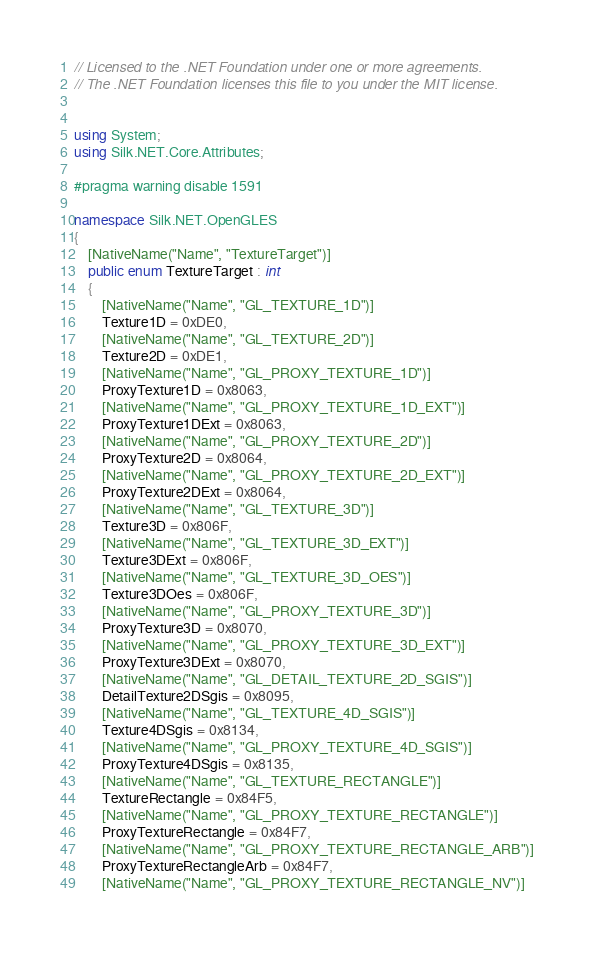<code> <loc_0><loc_0><loc_500><loc_500><_C#_>// Licensed to the .NET Foundation under one or more agreements.
// The .NET Foundation licenses this file to you under the MIT license.


using System;
using Silk.NET.Core.Attributes;

#pragma warning disable 1591

namespace Silk.NET.OpenGLES
{
    [NativeName("Name", "TextureTarget")]
    public enum TextureTarget : int
    {
        [NativeName("Name", "GL_TEXTURE_1D")]
        Texture1D = 0xDE0,
        [NativeName("Name", "GL_TEXTURE_2D")]
        Texture2D = 0xDE1,
        [NativeName("Name", "GL_PROXY_TEXTURE_1D")]
        ProxyTexture1D = 0x8063,
        [NativeName("Name", "GL_PROXY_TEXTURE_1D_EXT")]
        ProxyTexture1DExt = 0x8063,
        [NativeName("Name", "GL_PROXY_TEXTURE_2D")]
        ProxyTexture2D = 0x8064,
        [NativeName("Name", "GL_PROXY_TEXTURE_2D_EXT")]
        ProxyTexture2DExt = 0x8064,
        [NativeName("Name", "GL_TEXTURE_3D")]
        Texture3D = 0x806F,
        [NativeName("Name", "GL_TEXTURE_3D_EXT")]
        Texture3DExt = 0x806F,
        [NativeName("Name", "GL_TEXTURE_3D_OES")]
        Texture3DOes = 0x806F,
        [NativeName("Name", "GL_PROXY_TEXTURE_3D")]
        ProxyTexture3D = 0x8070,
        [NativeName("Name", "GL_PROXY_TEXTURE_3D_EXT")]
        ProxyTexture3DExt = 0x8070,
        [NativeName("Name", "GL_DETAIL_TEXTURE_2D_SGIS")]
        DetailTexture2DSgis = 0x8095,
        [NativeName("Name", "GL_TEXTURE_4D_SGIS")]
        Texture4DSgis = 0x8134,
        [NativeName("Name", "GL_PROXY_TEXTURE_4D_SGIS")]
        ProxyTexture4DSgis = 0x8135,
        [NativeName("Name", "GL_TEXTURE_RECTANGLE")]
        TextureRectangle = 0x84F5,
        [NativeName("Name", "GL_PROXY_TEXTURE_RECTANGLE")]
        ProxyTextureRectangle = 0x84F7,
        [NativeName("Name", "GL_PROXY_TEXTURE_RECTANGLE_ARB")]
        ProxyTextureRectangleArb = 0x84F7,
        [NativeName("Name", "GL_PROXY_TEXTURE_RECTANGLE_NV")]</code> 